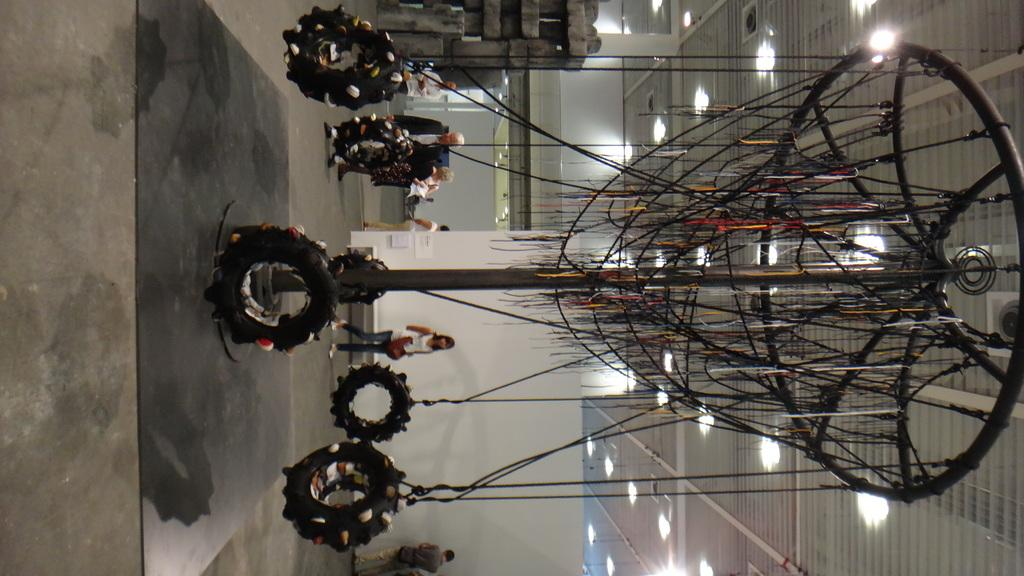What objects are present in the image that are related to transportation? There are tires with ropes in the image. What can be seen in the background of the image? There are people and a wall visible in the background of the image. What is illuminating the area in the image? There are lights visible at the top of the image. What type of snail can be seen crawling on the tires in the image? There are no snails present in the image; it features tires with ropes and a background with people and a wall. Where is the market located in the image? There is no market present in the image. 